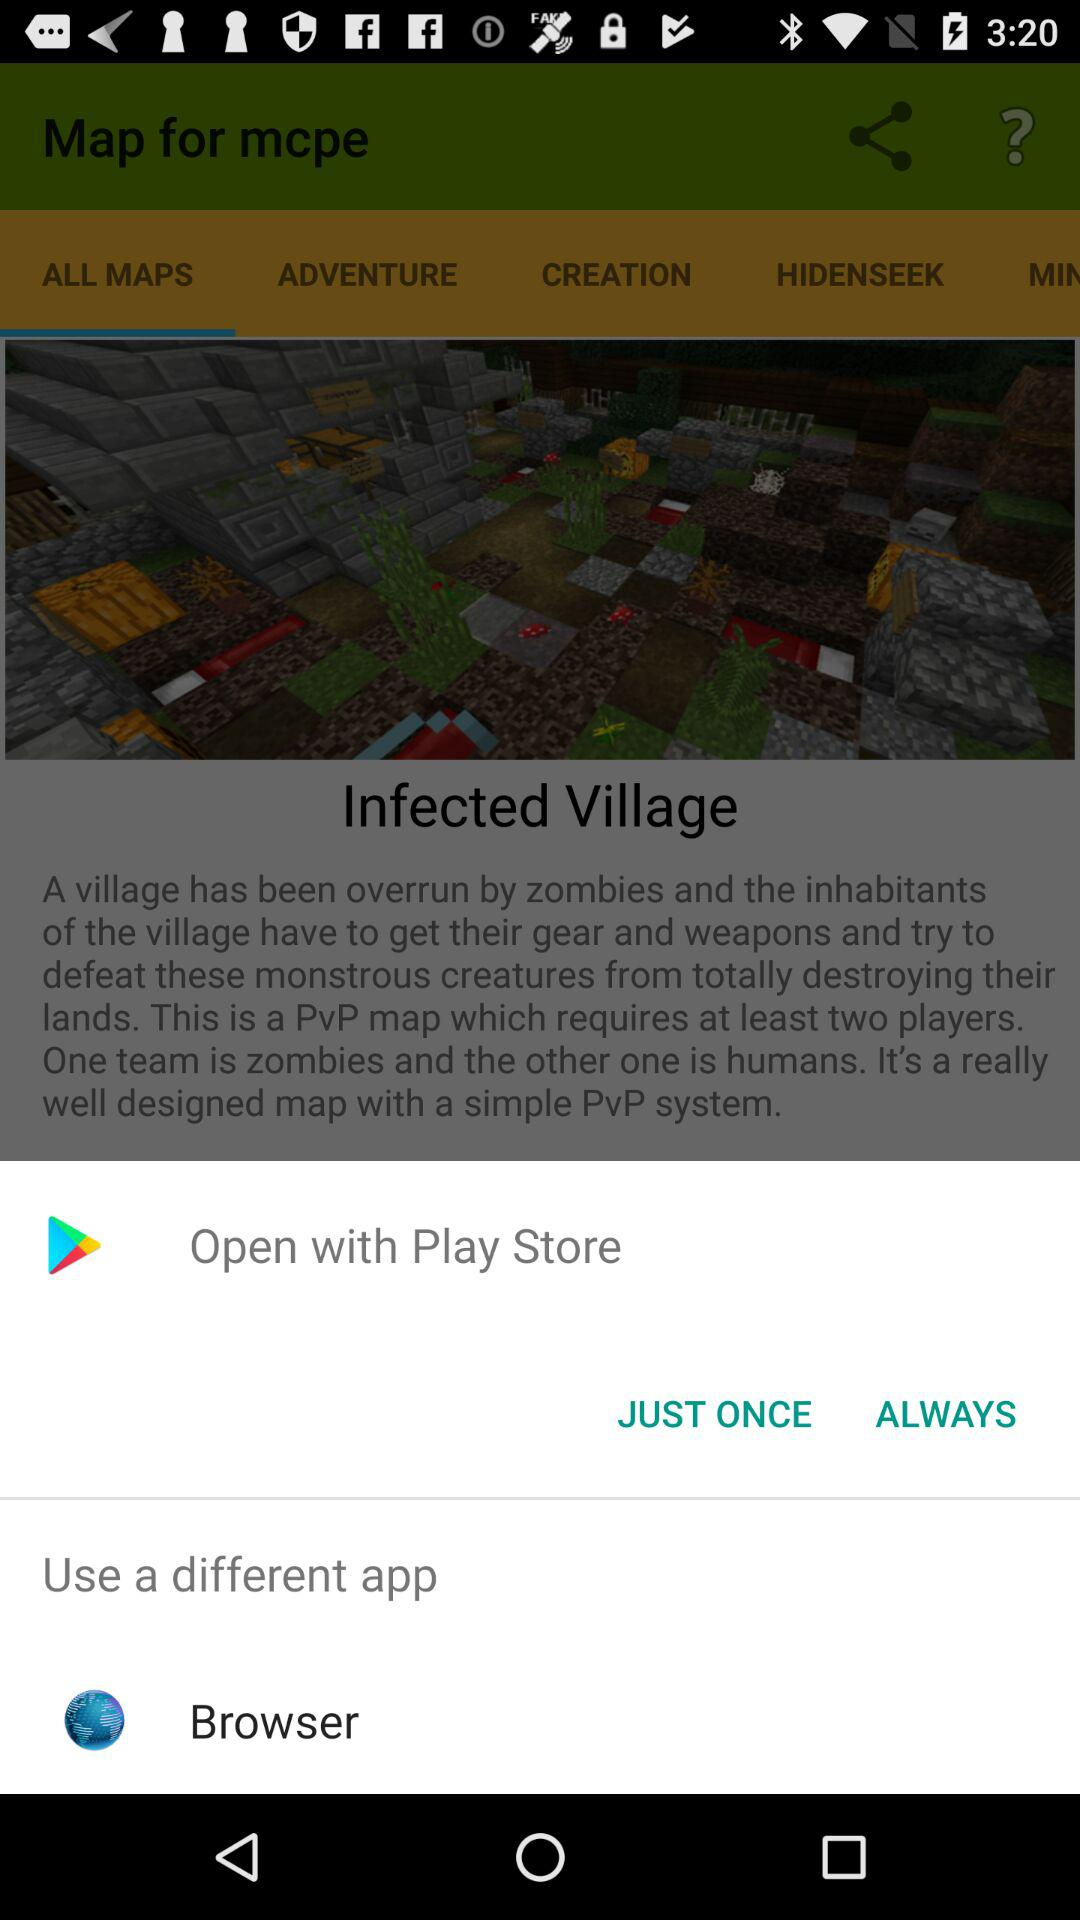What application can I use to open? The applications that you can use to open are "Play Store" and "Browser". 